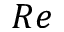<formula> <loc_0><loc_0><loc_500><loc_500>R e</formula> 